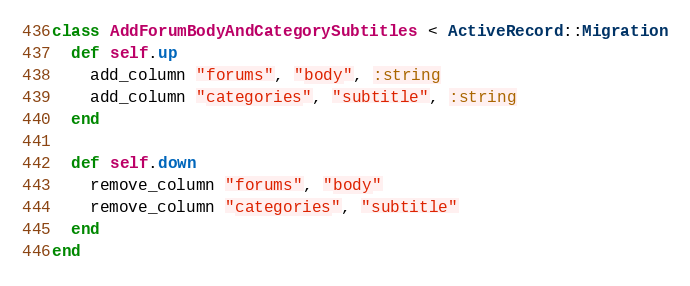<code> <loc_0><loc_0><loc_500><loc_500><_Ruby_>class AddForumBodyAndCategorySubtitles < ActiveRecord::Migration
  def self.up
    add_column "forums", "body", :string
    add_column "categories", "subtitle", :string
  end

  def self.down
    remove_column "forums", "body"
    remove_column "categories", "subtitle"
  end
end
</code> 